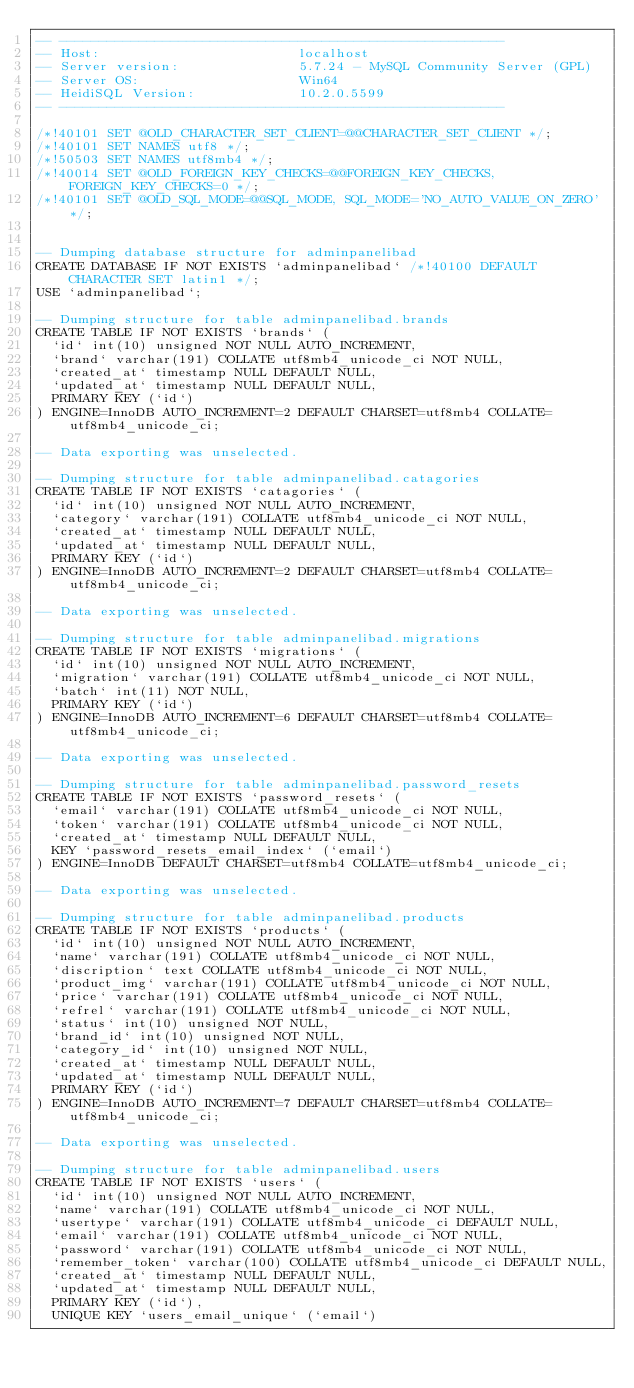Convert code to text. <code><loc_0><loc_0><loc_500><loc_500><_SQL_>-- --------------------------------------------------------
-- Host:                         localhost
-- Server version:               5.7.24 - MySQL Community Server (GPL)
-- Server OS:                    Win64
-- HeidiSQL Version:             10.2.0.5599
-- --------------------------------------------------------

/*!40101 SET @OLD_CHARACTER_SET_CLIENT=@@CHARACTER_SET_CLIENT */;
/*!40101 SET NAMES utf8 */;
/*!50503 SET NAMES utf8mb4 */;
/*!40014 SET @OLD_FOREIGN_KEY_CHECKS=@@FOREIGN_KEY_CHECKS, FOREIGN_KEY_CHECKS=0 */;
/*!40101 SET @OLD_SQL_MODE=@@SQL_MODE, SQL_MODE='NO_AUTO_VALUE_ON_ZERO' */;


-- Dumping database structure for adminpanelibad
CREATE DATABASE IF NOT EXISTS `adminpanelibad` /*!40100 DEFAULT CHARACTER SET latin1 */;
USE `adminpanelibad`;

-- Dumping structure for table adminpanelibad.brands
CREATE TABLE IF NOT EXISTS `brands` (
  `id` int(10) unsigned NOT NULL AUTO_INCREMENT,
  `brand` varchar(191) COLLATE utf8mb4_unicode_ci NOT NULL,
  `created_at` timestamp NULL DEFAULT NULL,
  `updated_at` timestamp NULL DEFAULT NULL,
  PRIMARY KEY (`id`)
) ENGINE=InnoDB AUTO_INCREMENT=2 DEFAULT CHARSET=utf8mb4 COLLATE=utf8mb4_unicode_ci;

-- Data exporting was unselected.

-- Dumping structure for table adminpanelibad.catagories
CREATE TABLE IF NOT EXISTS `catagories` (
  `id` int(10) unsigned NOT NULL AUTO_INCREMENT,
  `category` varchar(191) COLLATE utf8mb4_unicode_ci NOT NULL,
  `created_at` timestamp NULL DEFAULT NULL,
  `updated_at` timestamp NULL DEFAULT NULL,
  PRIMARY KEY (`id`)
) ENGINE=InnoDB AUTO_INCREMENT=2 DEFAULT CHARSET=utf8mb4 COLLATE=utf8mb4_unicode_ci;

-- Data exporting was unselected.

-- Dumping structure for table adminpanelibad.migrations
CREATE TABLE IF NOT EXISTS `migrations` (
  `id` int(10) unsigned NOT NULL AUTO_INCREMENT,
  `migration` varchar(191) COLLATE utf8mb4_unicode_ci NOT NULL,
  `batch` int(11) NOT NULL,
  PRIMARY KEY (`id`)
) ENGINE=InnoDB AUTO_INCREMENT=6 DEFAULT CHARSET=utf8mb4 COLLATE=utf8mb4_unicode_ci;

-- Data exporting was unselected.

-- Dumping structure for table adminpanelibad.password_resets
CREATE TABLE IF NOT EXISTS `password_resets` (
  `email` varchar(191) COLLATE utf8mb4_unicode_ci NOT NULL,
  `token` varchar(191) COLLATE utf8mb4_unicode_ci NOT NULL,
  `created_at` timestamp NULL DEFAULT NULL,
  KEY `password_resets_email_index` (`email`)
) ENGINE=InnoDB DEFAULT CHARSET=utf8mb4 COLLATE=utf8mb4_unicode_ci;

-- Data exporting was unselected.

-- Dumping structure for table adminpanelibad.products
CREATE TABLE IF NOT EXISTS `products` (
  `id` int(10) unsigned NOT NULL AUTO_INCREMENT,
  `name` varchar(191) COLLATE utf8mb4_unicode_ci NOT NULL,
  `discription` text COLLATE utf8mb4_unicode_ci NOT NULL,
  `product_img` varchar(191) COLLATE utf8mb4_unicode_ci NOT NULL,
  `price` varchar(191) COLLATE utf8mb4_unicode_ci NOT NULL,
  `refrel` varchar(191) COLLATE utf8mb4_unicode_ci NOT NULL,
  `status` int(10) unsigned NOT NULL,
  `brand_id` int(10) unsigned NOT NULL,
  `category_id` int(10) unsigned NOT NULL,
  `created_at` timestamp NULL DEFAULT NULL,
  `updated_at` timestamp NULL DEFAULT NULL,
  PRIMARY KEY (`id`)
) ENGINE=InnoDB AUTO_INCREMENT=7 DEFAULT CHARSET=utf8mb4 COLLATE=utf8mb4_unicode_ci;

-- Data exporting was unselected.

-- Dumping structure for table adminpanelibad.users
CREATE TABLE IF NOT EXISTS `users` (
  `id` int(10) unsigned NOT NULL AUTO_INCREMENT,
  `name` varchar(191) COLLATE utf8mb4_unicode_ci NOT NULL,
  `usertype` varchar(191) COLLATE utf8mb4_unicode_ci DEFAULT NULL,
  `email` varchar(191) COLLATE utf8mb4_unicode_ci NOT NULL,
  `password` varchar(191) COLLATE utf8mb4_unicode_ci NOT NULL,
  `remember_token` varchar(100) COLLATE utf8mb4_unicode_ci DEFAULT NULL,
  `created_at` timestamp NULL DEFAULT NULL,
  `updated_at` timestamp NULL DEFAULT NULL,
  PRIMARY KEY (`id`),
  UNIQUE KEY `users_email_unique` (`email`)</code> 